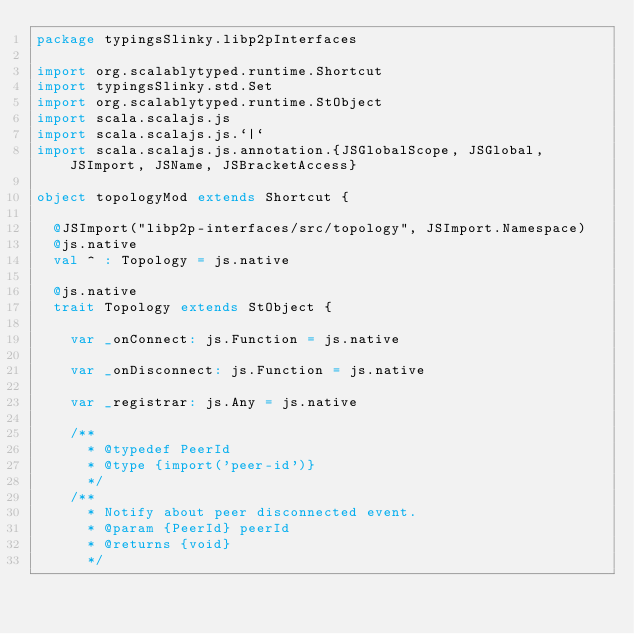Convert code to text. <code><loc_0><loc_0><loc_500><loc_500><_Scala_>package typingsSlinky.libp2pInterfaces

import org.scalablytyped.runtime.Shortcut
import typingsSlinky.std.Set
import org.scalablytyped.runtime.StObject
import scala.scalajs.js
import scala.scalajs.js.`|`
import scala.scalajs.js.annotation.{JSGlobalScope, JSGlobal, JSImport, JSName, JSBracketAccess}

object topologyMod extends Shortcut {
  
  @JSImport("libp2p-interfaces/src/topology", JSImport.Namespace)
  @js.native
  val ^ : Topology = js.native
  
  @js.native
  trait Topology extends StObject {
    
    var _onConnect: js.Function = js.native
    
    var _onDisconnect: js.Function = js.native
    
    var _registrar: js.Any = js.native
    
    /**
      * @typedef PeerId
      * @type {import('peer-id')}
      */
    /**
      * Notify about peer disconnected event.
      * @param {PeerId} peerId
      * @returns {void}
      */</code> 